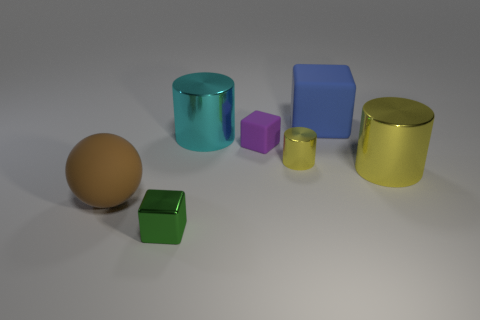Imagine these objects are part of a children's toy set. What sort of game could they be used for? Imagining these as part of a toy set, they could be used in a creative learning game where children could practice sorting by color, shape, or size. Additionally, they could be used in a construction or balancing game, challenging kids to stack them without toppling, or in imaginative play as various items in miniature worlds. 